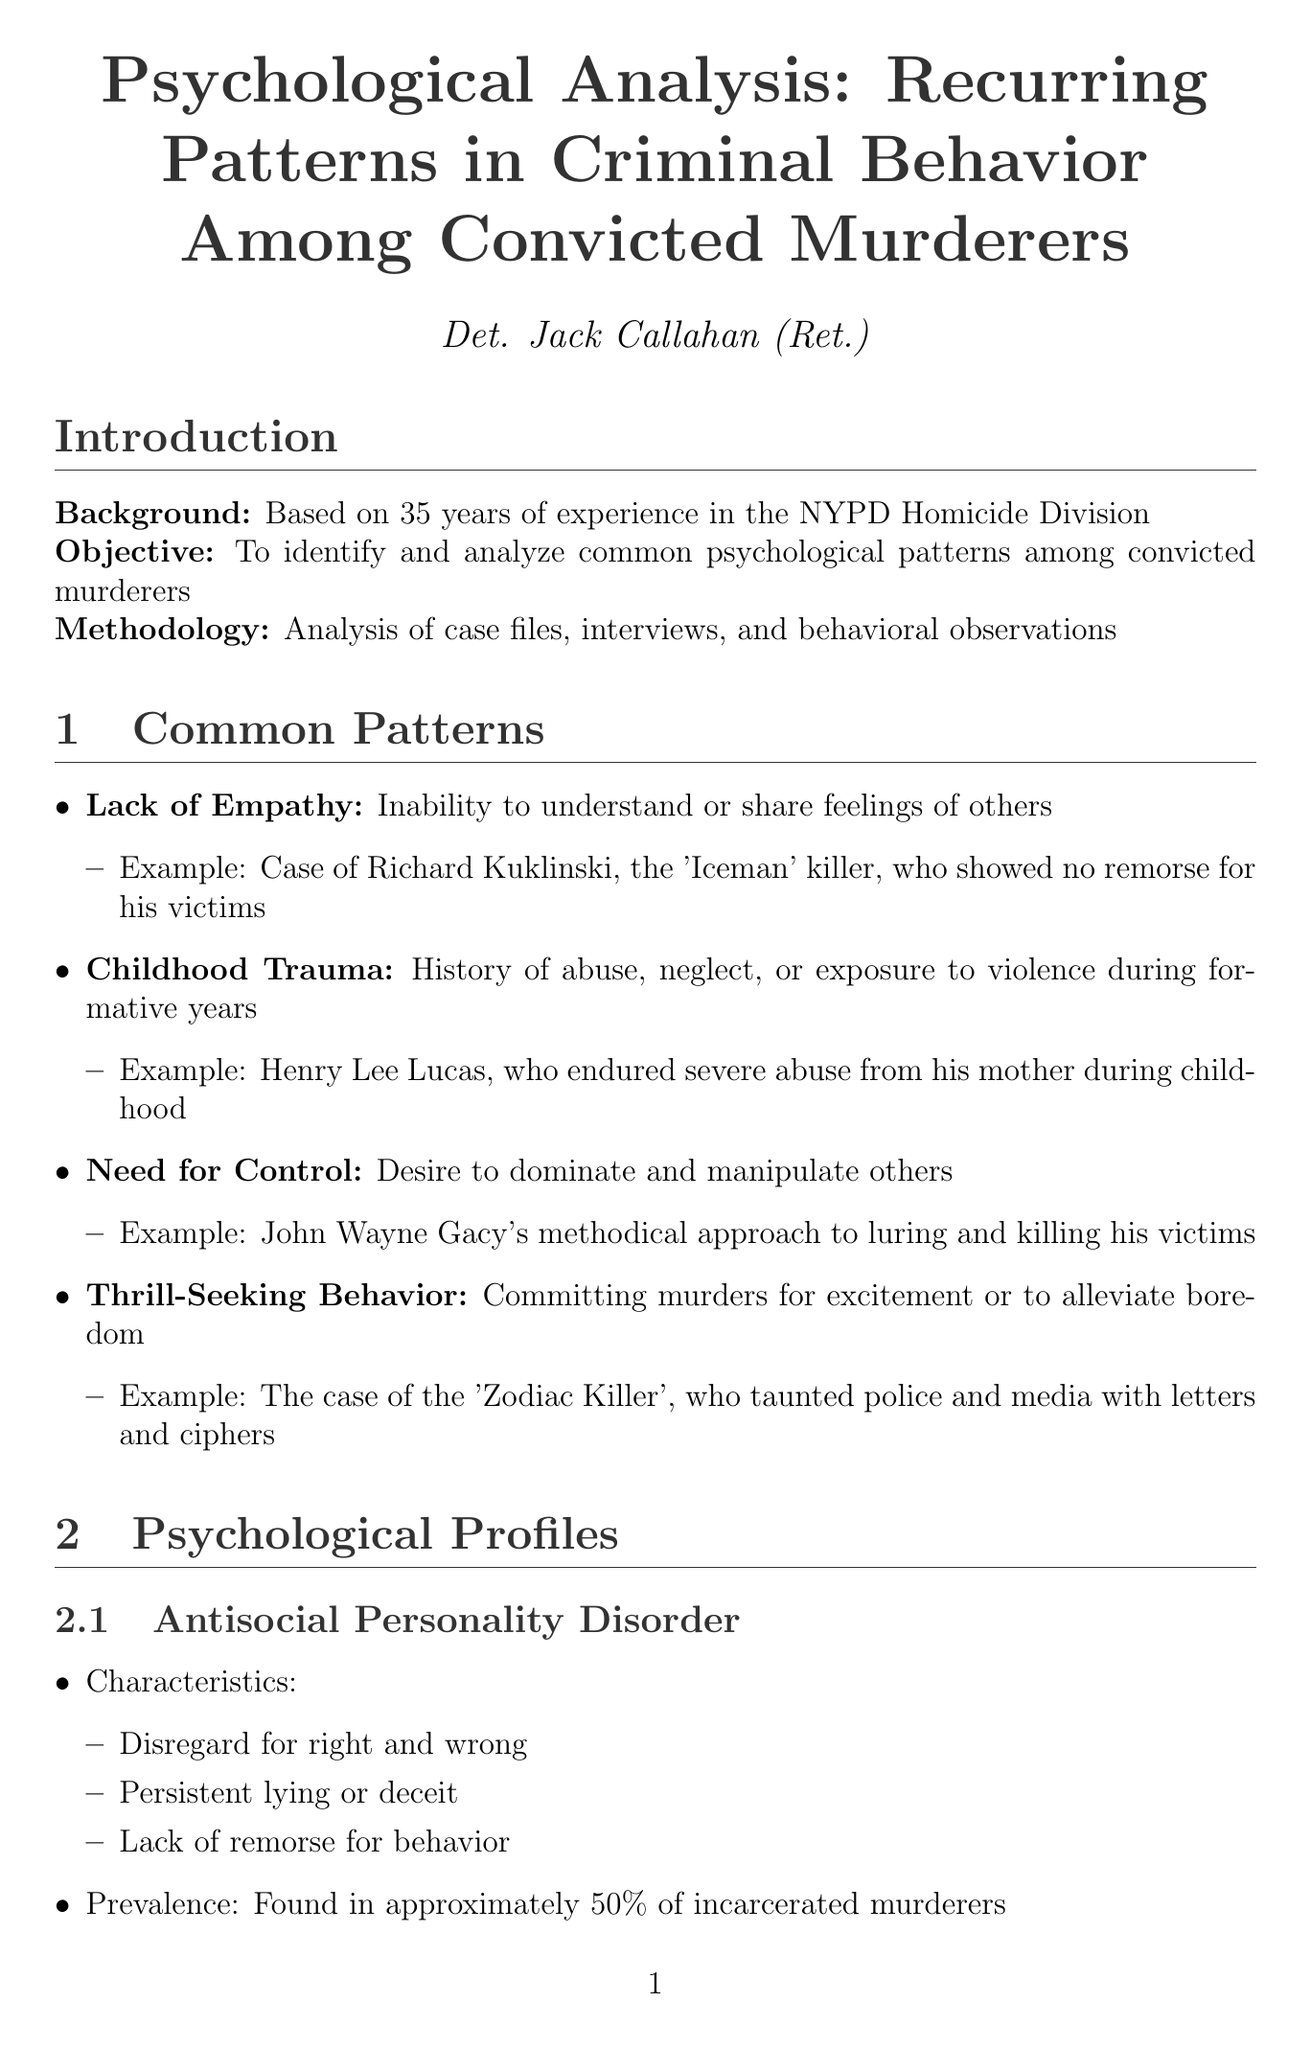What is the report title? The report title is stated at the beginning of the document.
Answer: Psychological Analysis: Recurring Patterns in Criminal Behavior Among Convicted Murderers Who is the author of the report? The author of the report is mentioned in the title section.
Answer: Det. Jack Callahan (Ret.) What is the percentage of incarcerated murderers found to have Antisocial Personality Disorder? The prevalence of Antisocial Personality Disorder among incarcerated murderers is provided in the psychological profiles section.
Answer: approximately 50% Name one example of childhood trauma. An example is given in the common patterns section where a specific case is mentioned.
Answer: Henry Lee Lucas What is the impact of social isolation according to the report? The report describes the impact of social isolation in the environmental factors section.
Answer: Lack of social connections can lead to detachment from societal norms What percentage of released murderers are rearrested within three years? The statistical data about rearrest is stated in the recidivism analysis section.
Answer: 68% Identify one contributing factor to recidivism mentioned in the document. Contributing factors are listed in the recidivism analysis section.
Answer: Lack of rehabilitation programs What is the main implication of understanding recurring patterns in criminal behavior? The implications are summarized in the conclusion section.
Answer: Aid in prevention, early intervention, and more effective rehabilitation strategies 